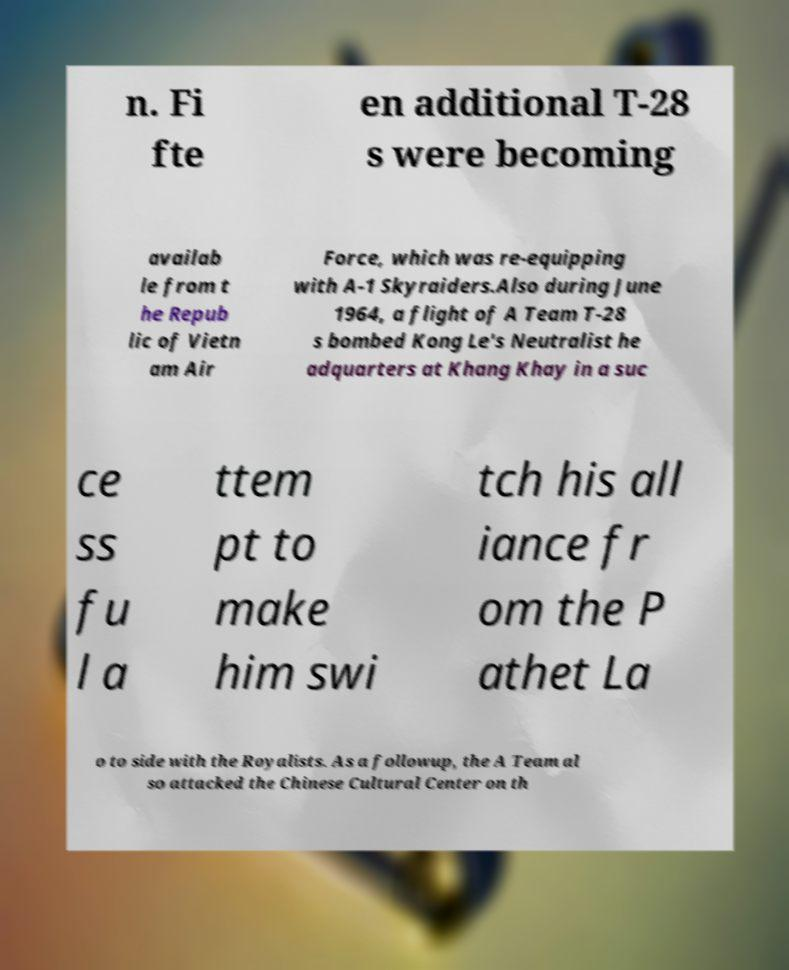Please identify and transcribe the text found in this image. n. Fi fte en additional T-28 s were becoming availab le from t he Repub lic of Vietn am Air Force, which was re-equipping with A-1 Skyraiders.Also during June 1964, a flight of A Team T-28 s bombed Kong Le's Neutralist he adquarters at Khang Khay in a suc ce ss fu l a ttem pt to make him swi tch his all iance fr om the P athet La o to side with the Royalists. As a followup, the A Team al so attacked the Chinese Cultural Center on th 